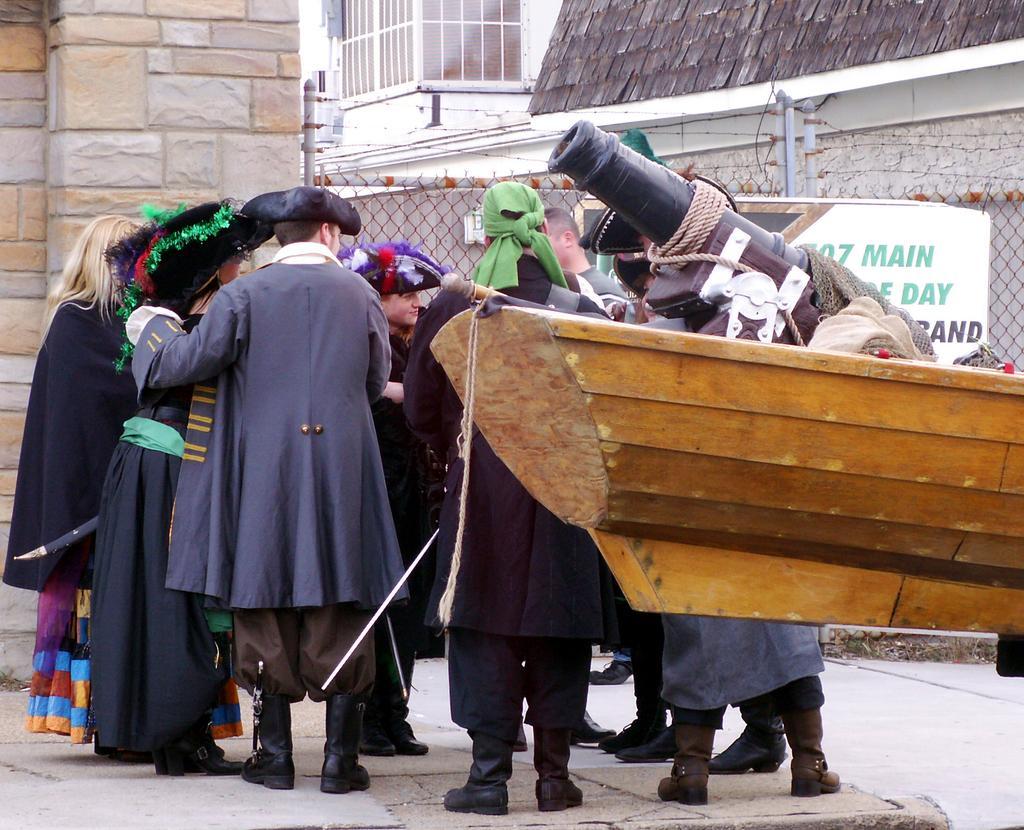How would you summarize this image in a sentence or two? In this image, we can see a group of people are standing on the path. On the right side of the image, we can see a wooden object. Background we can see the mesh, banner, walls, poles, wires and glass object. 